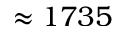Convert formula to latex. <formula><loc_0><loc_0><loc_500><loc_500>\approx 1 7 3 5</formula> 